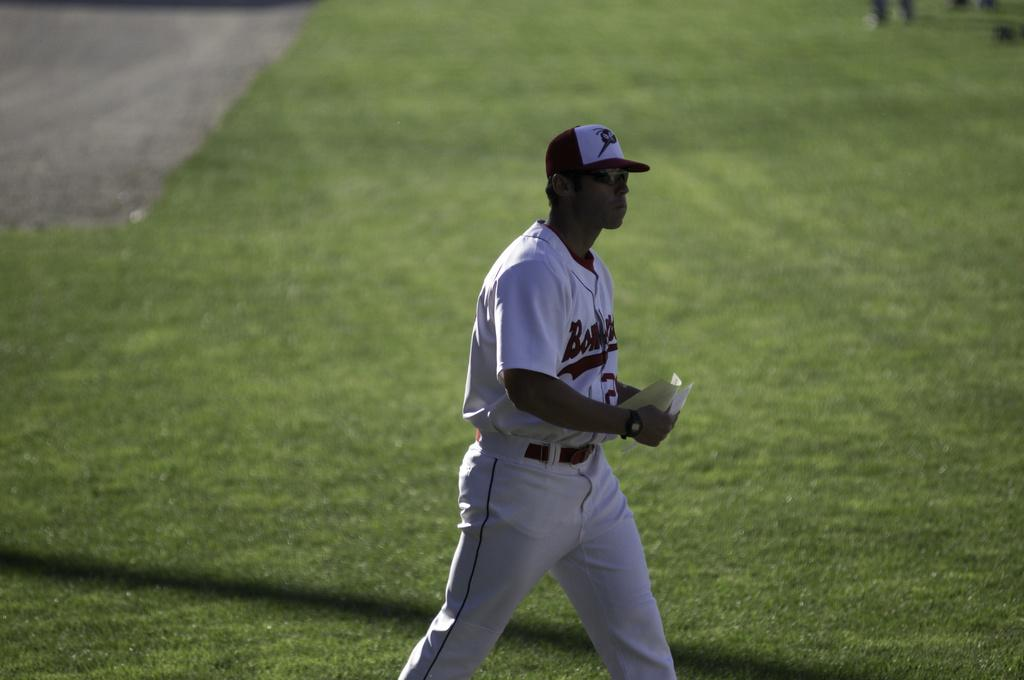<image>
Share a concise interpretation of the image provided. A baseball player in a uniform with the partial word Bon on the front. 